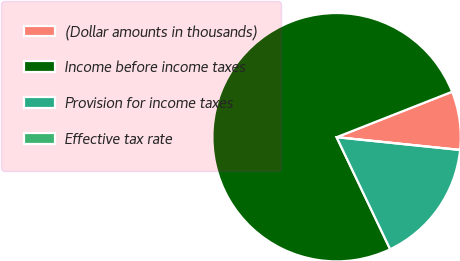<chart> <loc_0><loc_0><loc_500><loc_500><pie_chart><fcel>(Dollar amounts in thousands)<fcel>Income before income taxes<fcel>Provision for income taxes<fcel>Effective tax rate<nl><fcel>7.61%<fcel>76.13%<fcel>16.26%<fcel>0.0%<nl></chart> 